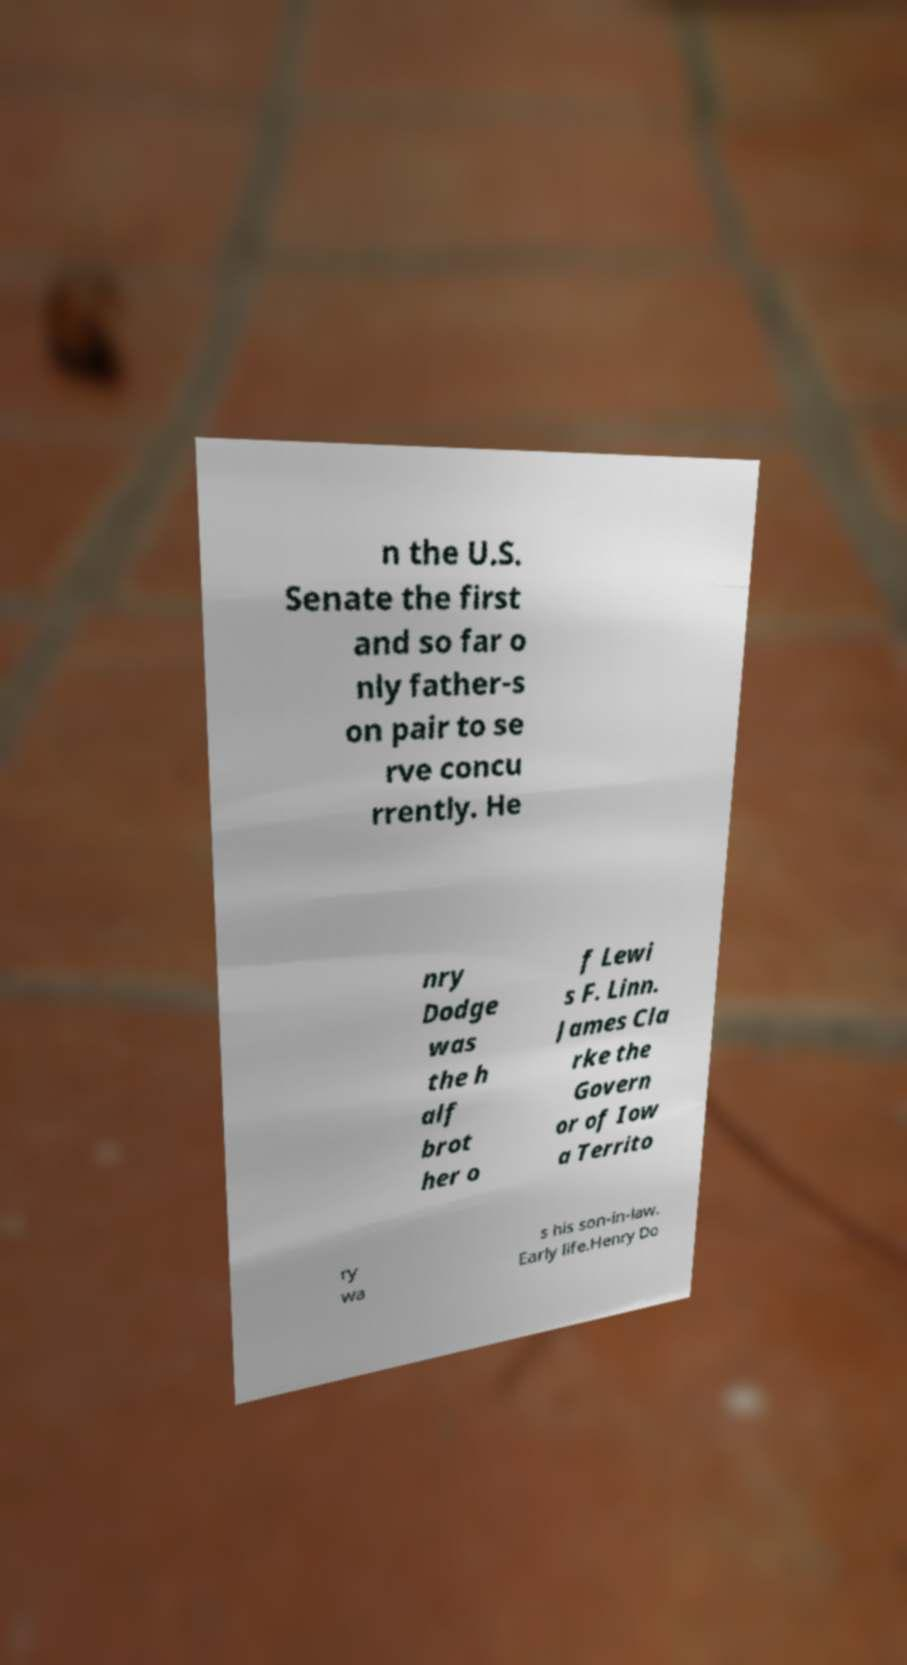I need the written content from this picture converted into text. Can you do that? n the U.S. Senate the first and so far o nly father-s on pair to se rve concu rrently. He nry Dodge was the h alf brot her o f Lewi s F. Linn. James Cla rke the Govern or of Iow a Territo ry wa s his son-in-law. Early life.Henry Do 